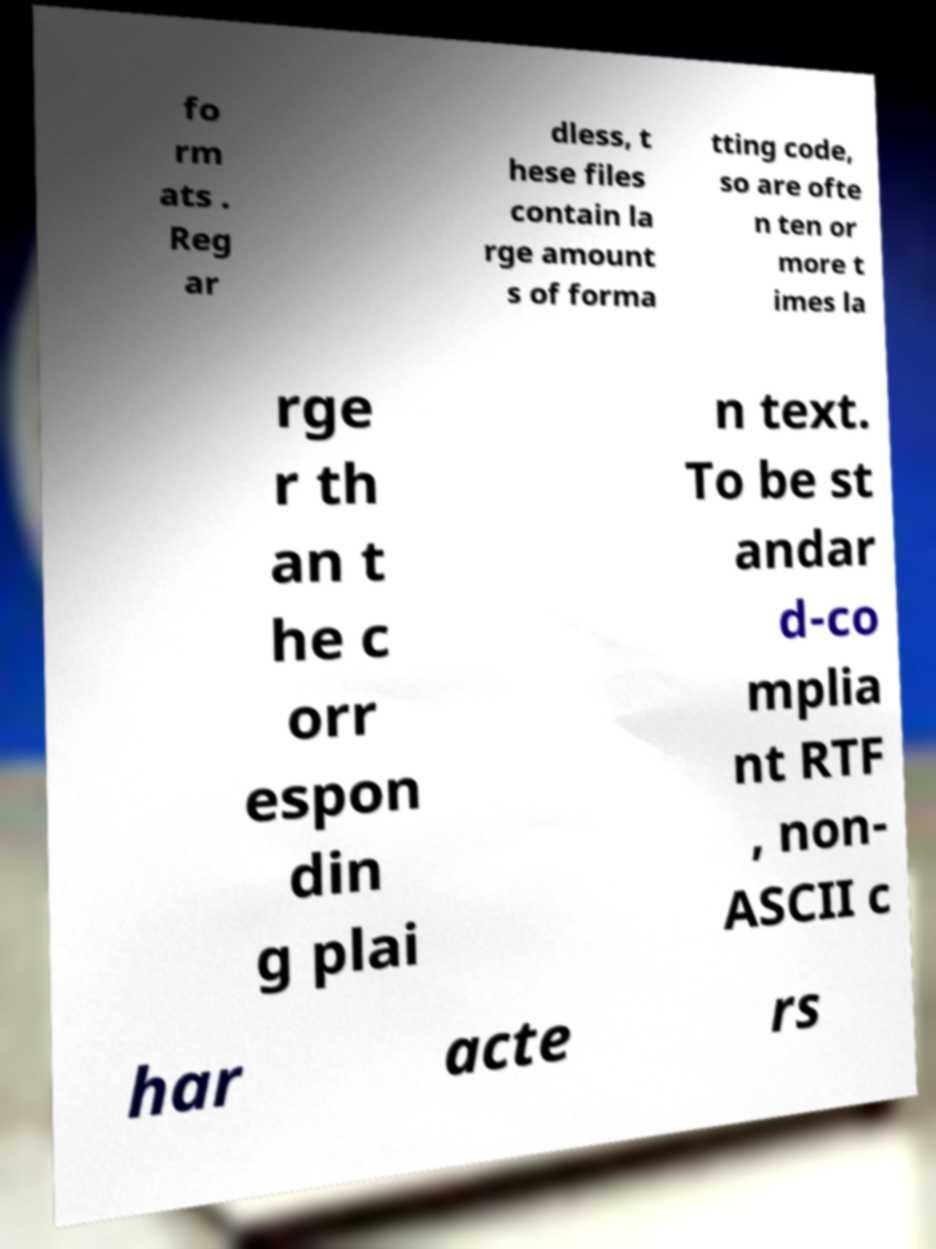Please read and relay the text visible in this image. What does it say? fo rm ats . Reg ar dless, t hese files contain la rge amount s of forma tting code, so are ofte n ten or more t imes la rge r th an t he c orr espon din g plai n text. To be st andar d-co mplia nt RTF , non- ASCII c har acte rs 